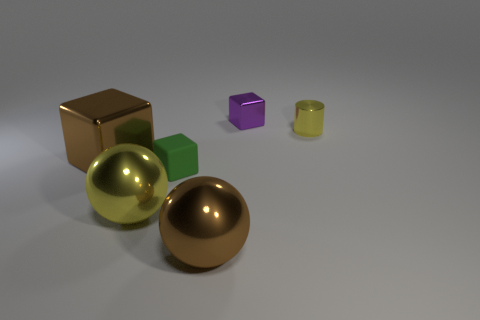Can you tell me the colors of the spherical objects? Certainly, there are two spherical objects, one is gold and the other is silver. 